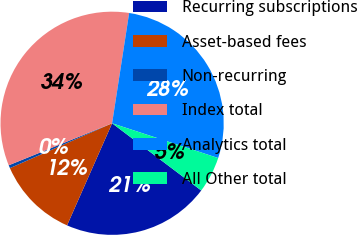Convert chart to OTSL. <chart><loc_0><loc_0><loc_500><loc_500><pie_chart><fcel>Recurring subscriptions<fcel>Asset-based fees<fcel>Non-recurring<fcel>Index total<fcel>Analytics total<fcel>All Other total<nl><fcel>21.33%<fcel>11.8%<fcel>0.44%<fcel>33.58%<fcel>27.6%<fcel>5.24%<nl></chart> 